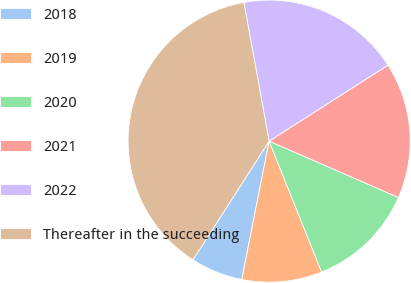Convert chart to OTSL. <chart><loc_0><loc_0><loc_500><loc_500><pie_chart><fcel>2018<fcel>2019<fcel>2020<fcel>2021<fcel>2022<fcel>Thereafter in the succeeding<nl><fcel>5.97%<fcel>9.18%<fcel>12.39%<fcel>15.6%<fcel>18.81%<fcel>38.06%<nl></chart> 